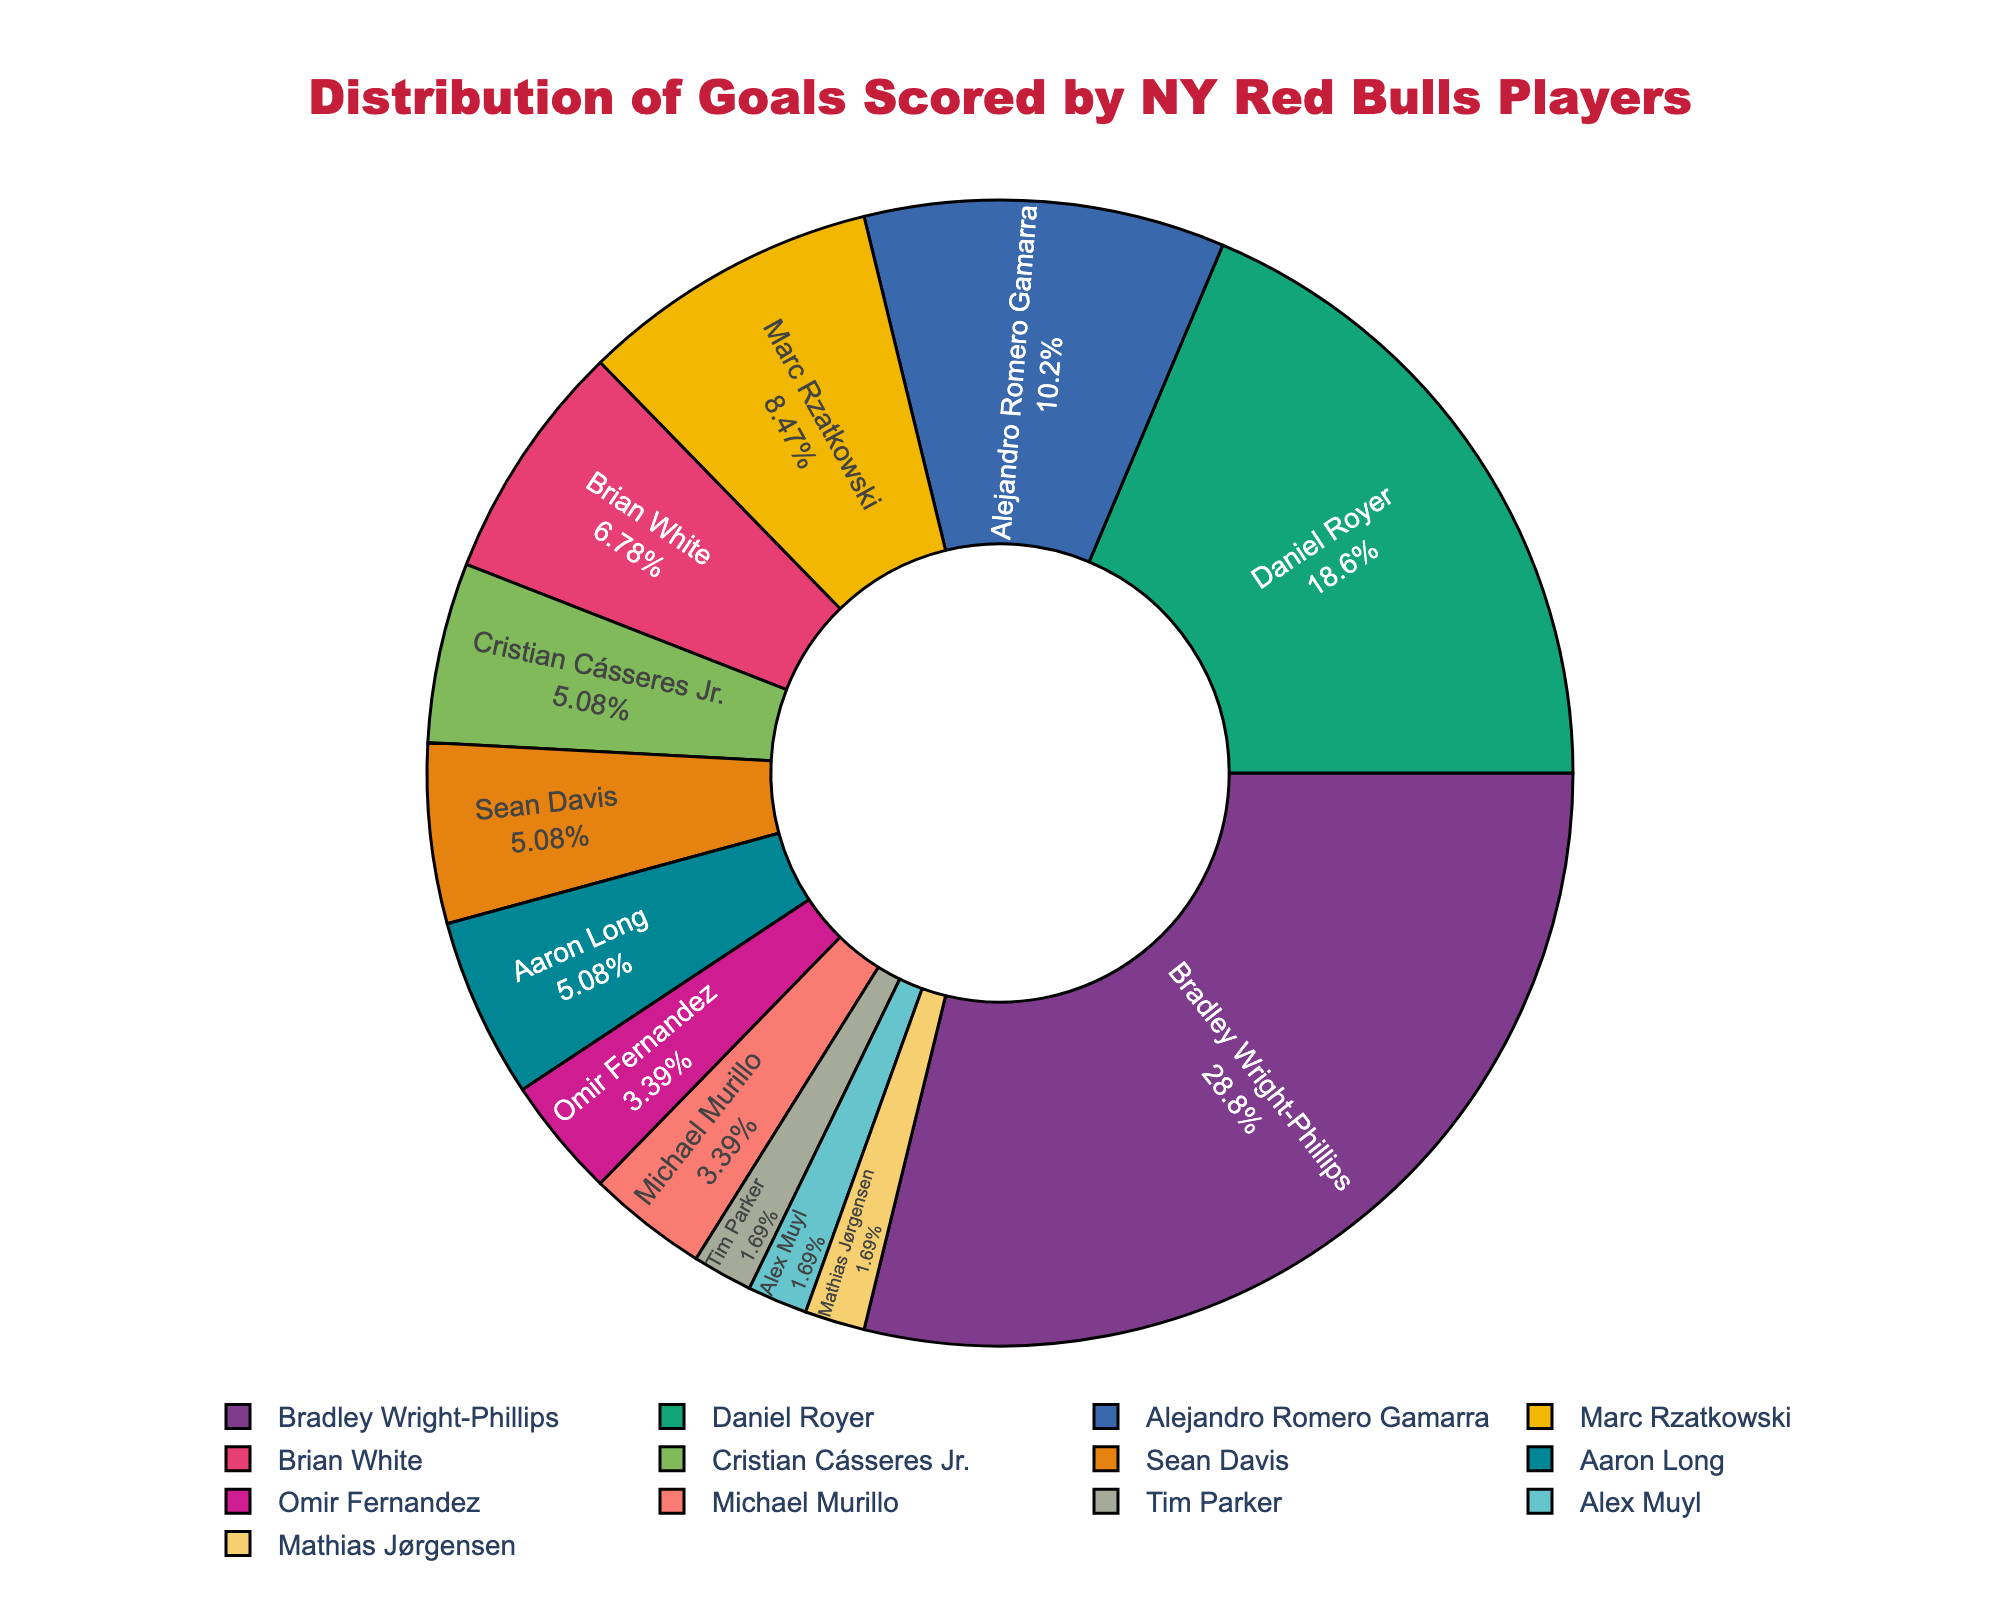Who scored the highest number of goals for the New York Red Bulls this season? Bradley Wright-Phillips scored the highest number of goals as indicated by the largest segment of the pie chart.
Answer: Bradley Wright-Phillips Which player has the second largest share of goals? Daniel Royer has the second-largest share of goals, visible through the second-largest segment in the pie chart.
Answer: Daniel Royer How many players scored exactly 3 goals? By counting the segments corresponding to players with 3 goals, there are three players: Cristian Cásseres Jr., Sean Davis, and Aaron Long.
Answer: 3 What is the combined percentage of goals scored by Bradley Wright-Phillips and Daniel Royer? Bradley Wright-Phillips and Daniel Royer scored 17 and 11 goals respectively. The total number of goals is 59. The combined percentage is (17+11)/59 * 100%.
Answer: 47.46% Who scored more goals: Brian White or Alejandro Romero Gamarra? The pie chart shows that Alejandro Romero Gamarra has a larger segment than Brian White, indicating he scored more goals.
Answer: Alejandro Romero Gamarra Compare the goal contributions of Bradley Wright-Phillips and the least-scoring players combined. Bradley Wright-Phillips scored 17 goals, while the least-scoring players (Tim Parker, Alex Muyl, and Mathias Jørgensen) combined scored 3 goals. 17 is greater than 3.
Answer: Bradley Wright-Phillips Which player has a segment next to Alejandro Romero Gamarra’s segment in the pie chart? The pie chart displays Marc Rzatkowski's segment adjacent to Alejandro Romero Gamarra’s segment.
Answer: Marc Rzatkowski What fraction of the total goals did Marc Rzatkowski score? Marc Rzatkowski scored 5 out of 59 total goals. The fraction is 5/59.
Answer: 5/59 Are there more players who scored exactly 2 goals than players who scored more than 4 goals? The pie chart shows two players scored exactly 2 goals (Omir Fernandez and Michael Murillo), while three players scored more than 4 goals (Bradley Wright-Phillips, Daniel Royer, and Alejandro Romero Gamarra). So, no.
Answer: No On average, how many goals did the players with 1 goal score? There are three players who scored 1 goal each. The average is (1+1+1)/3 = 1.
Answer: 1 